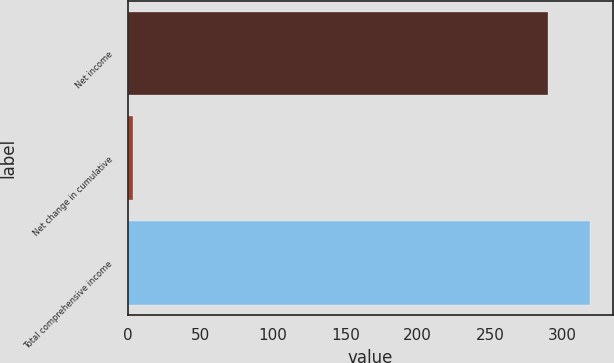Convert chart to OTSL. <chart><loc_0><loc_0><loc_500><loc_500><bar_chart><fcel>Net income<fcel>Net change in cumulative<fcel>Total comprehensive income<nl><fcel>289.7<fcel>3.8<fcel>318.67<nl></chart> 